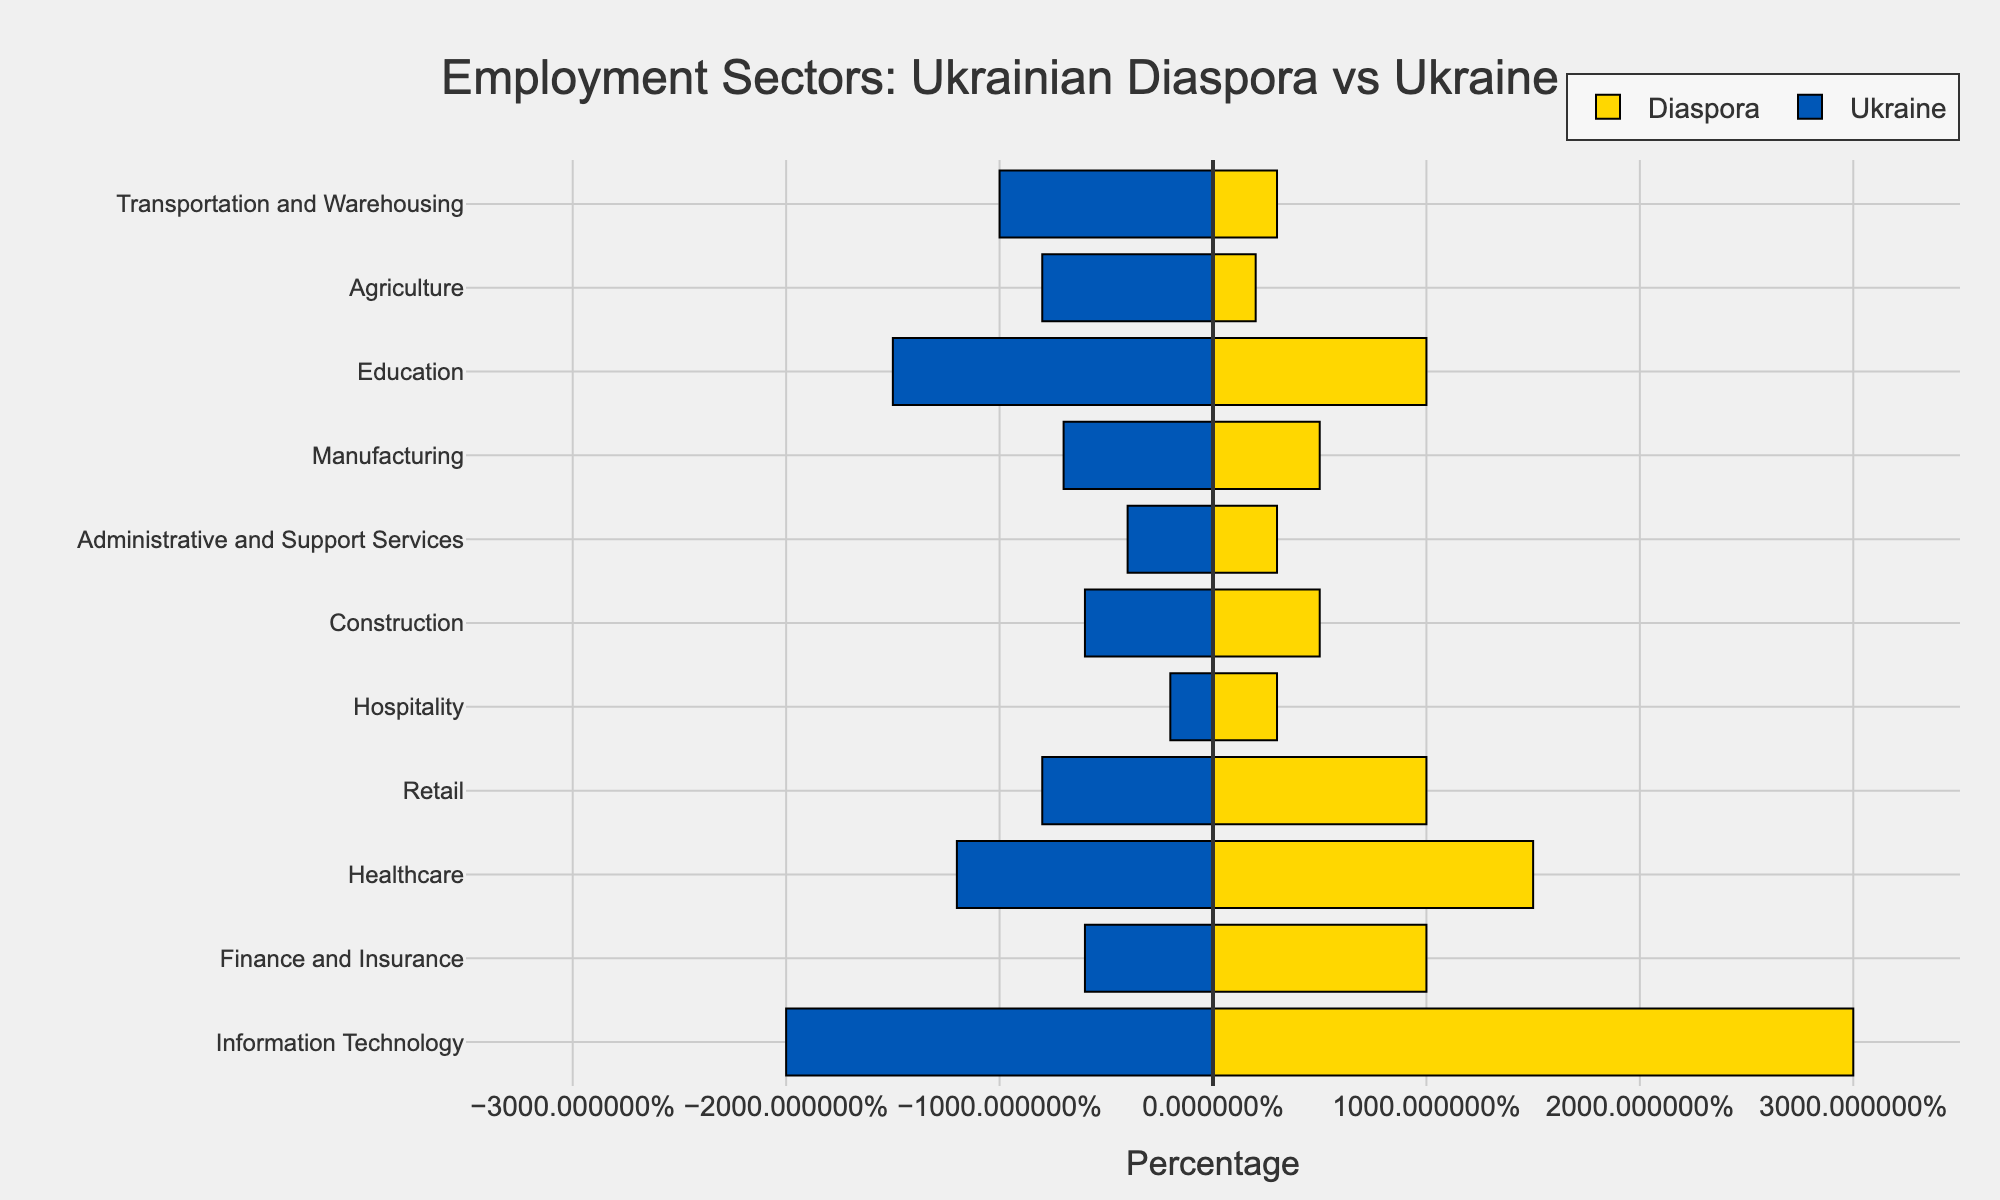What sector has the highest percentage difference in employment between the diaspora and Ukraine? The sector with the highest percentage difference is determined by the difference between the diaspora percentage and the Ukraine percentage, which is Information Technology. Using the provided data, Information Technology has a difference of 10% (30% in the diaspora vs. 20% in Ukraine).
Answer: Information Technology Which sector is more popular in Ukraine compared to the diaspora? To find the sector more popular in Ukraine, identify sectors where the Ukraine percentage is higher than the diaspora percentage. Transportation and Warehousing has 10% in Ukraine and 3% in the diaspora, thus a 7% difference in favor of Ukraine.
Answer: Transportation and Warehousing What is the cumulative percentage of employment in the Information Technology and Healthcare sectors in the diaspora? Sum the diaspora percentage of the Information Technology sector (30%) and the Healthcare sector (15%). Therefore, 30% + 15% = 45%.
Answer: 45% Among the sectors with a higher percentage in the diaspora, which sector has the smallest difference in employment between the diaspora and Ukraine? Identify the sectors where the diaspora percentage is higher and then find the smallest difference. Administrative and Support Services (3% in diaspora) and Hospitality (3% in diaspora) each have only a small 1% difference compared to Ukraine (4% in Ukraine for Administrative and Support Services and 2% for Hospitality).
Answer: Hospitality and Administrative and Support Services (both 1%) What is the total percentage of employment in the Retail and Manufacturing sectors in Ukraine? Sum the Ukraine percentages of the Retail sector (8%) and the Manufacturing sector (7%). Therefore, 8% + 7% = 15%.
Answer: 15% Which sectors have an equal percentage of employment in the diaspora? Look for sectors in the diaspora that have the same percentage of employment. Retail, Finance and Insurance both have 10% in the diaspora. Administrative and Support Services, Healthcare, and Hospitality each have 3% in the diaspora.
Answer: Retail and Finance and Insurance (both 10%); Administrative and Support Services, Healthcare, and Hospitality (each 3%) What is the average percentage of employment in the Agriculture and Construction sectors in Ukraine? Calculate the average by adding the percentages and dividing by the number of sectors. Agriculture (8%) and Construction (6%) in Ukraine, hence (8% + 6%) / 2 = 7%.
Answer: 7% In which sector is the percentage difference of employment smallest regardless of country of employment? For this, identify the sector with the minimal absolute difference between diaspora and Ukraine percentages. The smallest difference is for Hospitality which has 1% in the Ukraine and 2% in the diaspora resulting in a difference of 1%.
Answer: Hospitality Between Finance and Insurance and Education sectors, which one has a higher cumulative percentage in the diaspora? Sum the diaspora percentages of Finance and Insurance (10%) and Education (10%). Both sectors together are 20%, the comparison shows equal percentages.
Answer: Equal (Both 10%) What is the combined percentage of the top three sectors with the highest difference in diaspora percentages? Identify the top three sectors with the highest percentage in the diaspora (Information Technology, Healthcare, Education). Sum the diaspora percentages: 30% (Information Technology) + 15% (Healthcare) + 10% (Education) = 55%.
Answer: 55% 